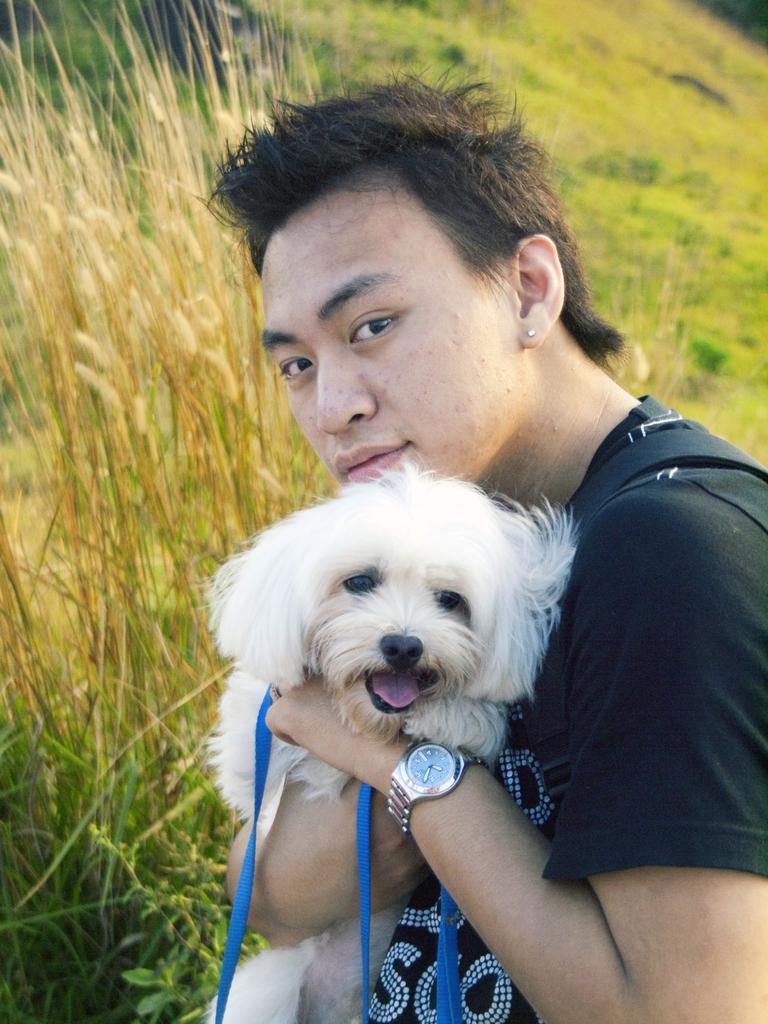How would you summarize this image in a sentence or two? In this image I can see a person holding a dog. The person is wearing black shirt and the dog is in white color. Background the grass is in brown and green color. 